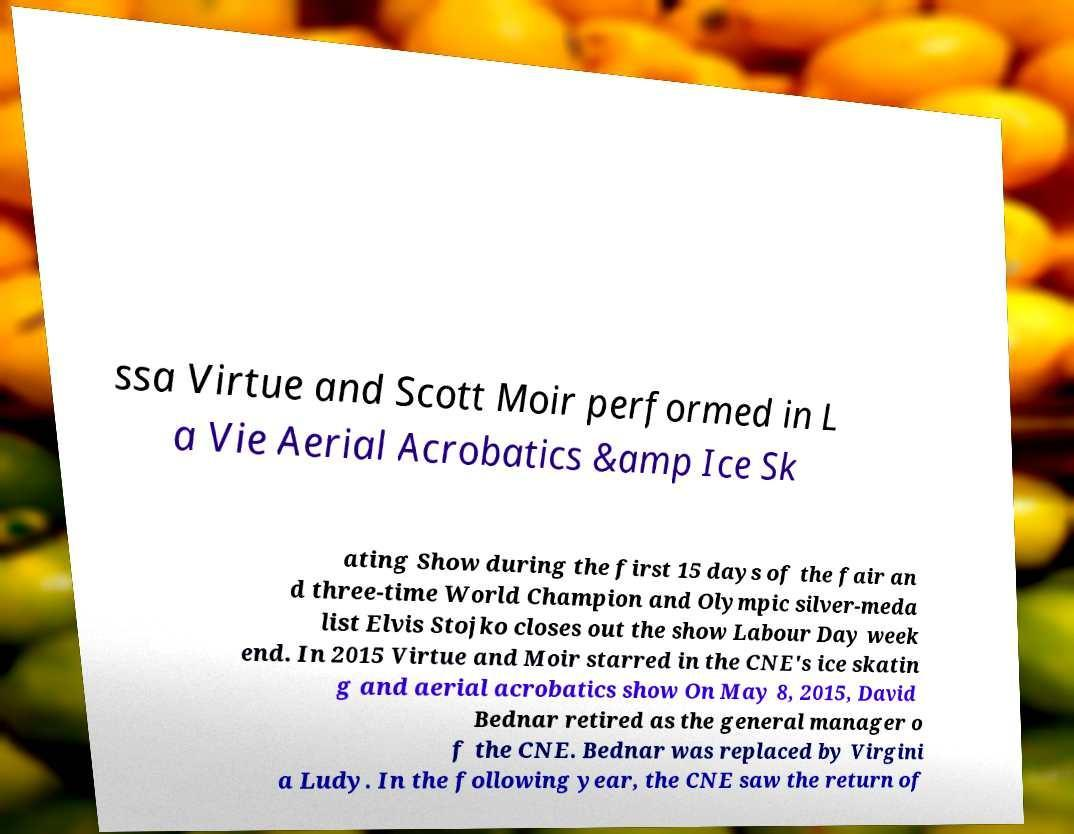Can you read and provide the text displayed in the image?This photo seems to have some interesting text. Can you extract and type it out for me? ssa Virtue and Scott Moir performed in L a Vie Aerial Acrobatics &amp Ice Sk ating Show during the first 15 days of the fair an d three-time World Champion and Olympic silver-meda list Elvis Stojko closes out the show Labour Day week end. In 2015 Virtue and Moir starred in the CNE's ice skatin g and aerial acrobatics show On May 8, 2015, David Bednar retired as the general manager o f the CNE. Bednar was replaced by Virgini a Ludy. In the following year, the CNE saw the return of 